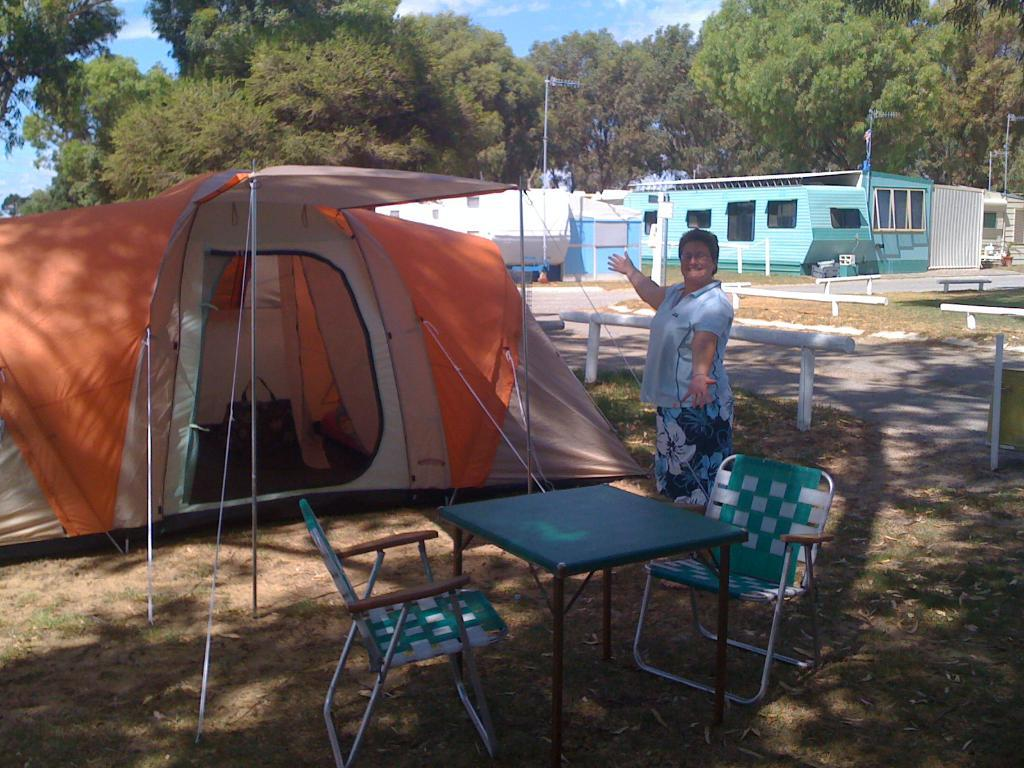What type of furniture is present in the image? There are chairs and a table in the image. What structure is also visible in the image? There is a tent in the image. Who is present in the image? A woman is standing in front of the chairs, table, and tent. What can be seen in the background of the image? There are buildings, poles, and trees in the background of the image. What type of wool is being spun by the fireman in the image? There is no wool or fireman present in the image. What time of day is it in the image, given the morning light? The time of day cannot be determined from the image, as there is no reference to lighting or time. 